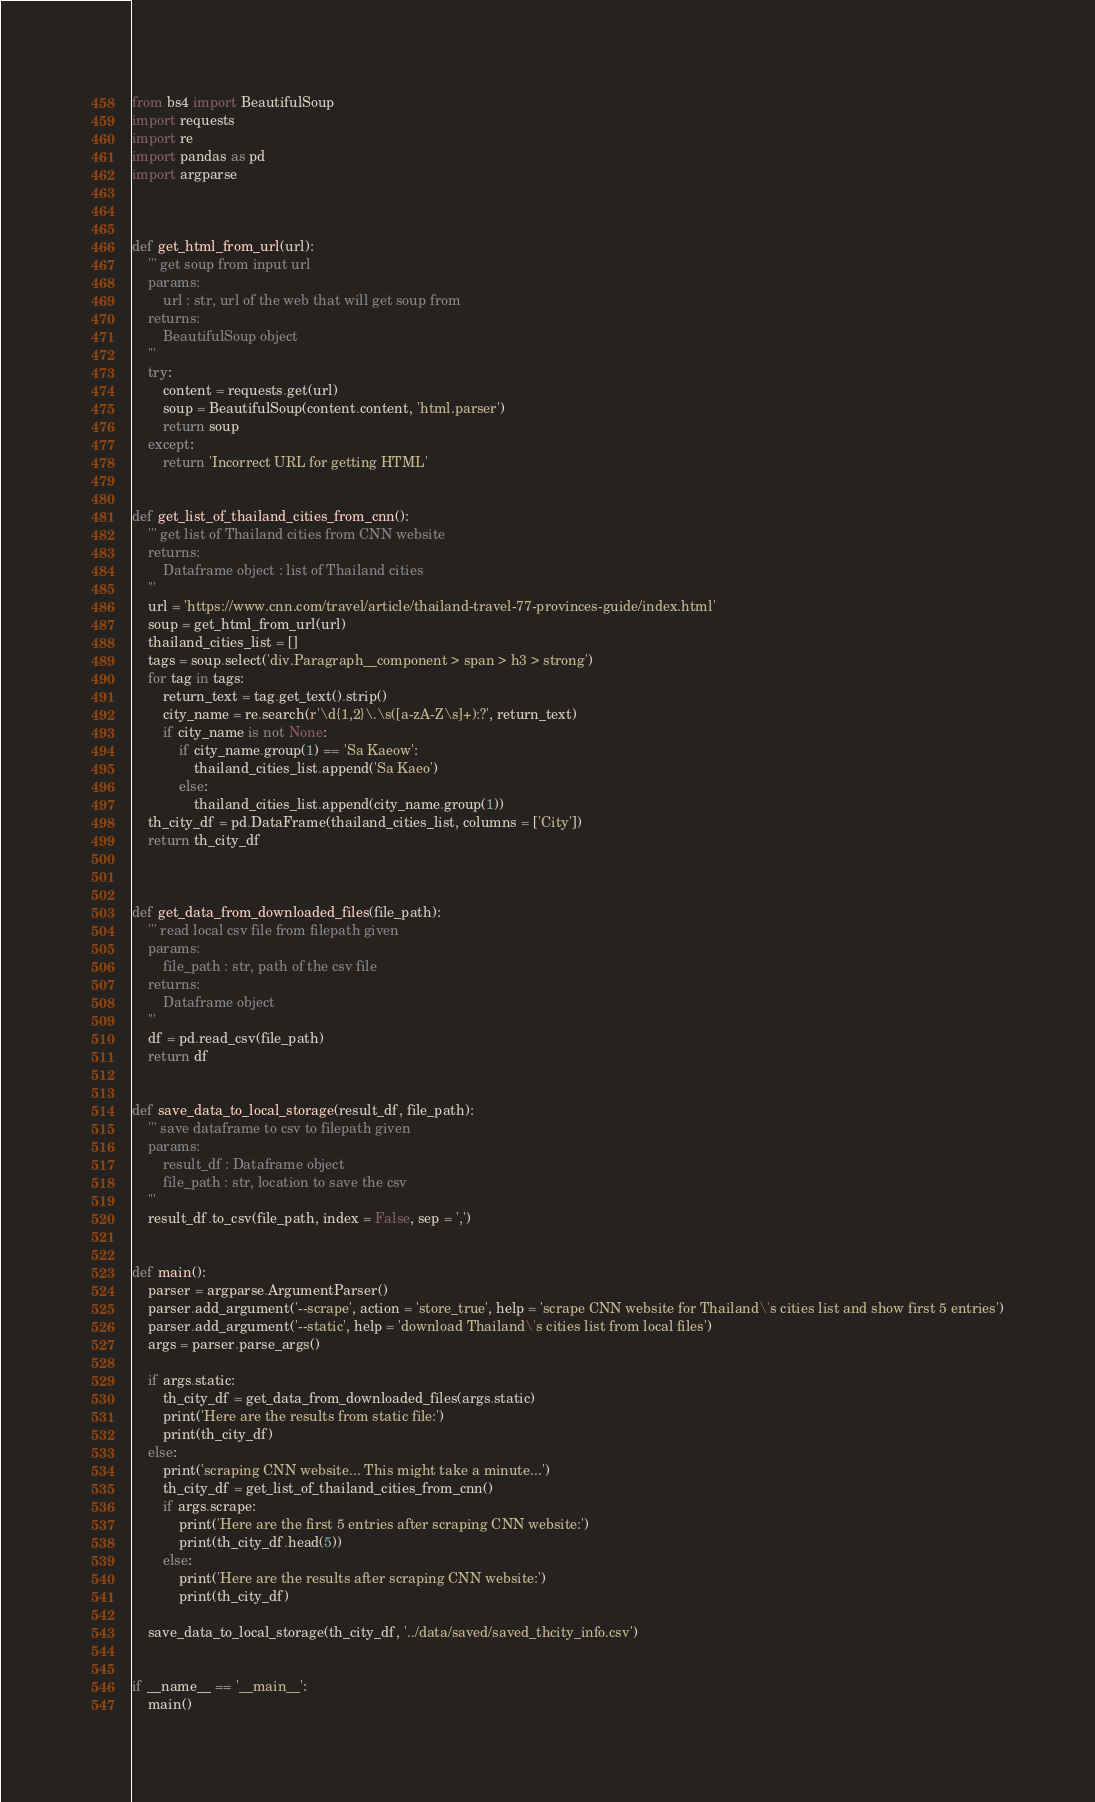<code> <loc_0><loc_0><loc_500><loc_500><_Python_>from bs4 import BeautifulSoup
import requests
import re
import pandas as pd
import argparse



def get_html_from_url(url):
    ''' get soup from input url
    params:
        url : str, url of the web that will get soup from
    returns: 
        BeautifulSoup object
    '''
    try:
        content = requests.get(url)
        soup = BeautifulSoup(content.content, 'html.parser')
        return soup
    except:
        return 'Incorrect URL for getting HTML'
    
    
def get_list_of_thailand_cities_from_cnn():
    ''' get list of Thailand cities from CNN website
    returns:
        Dataframe object : list of Thailand cities
    '''
    url = 'https://www.cnn.com/travel/article/thailand-travel-77-provinces-guide/index.html'
    soup = get_html_from_url(url)
    thailand_cities_list = []
    tags = soup.select('div.Paragraph__component > span > h3 > strong')
    for tag in tags:
        return_text = tag.get_text().strip()
        city_name = re.search(r'\d{1,2}\.\s([a-zA-Z\s]+):?', return_text)
        if city_name is not None:
            if city_name.group(1) == 'Sa Kaeow':
                thailand_cities_list.append('Sa Kaeo')
            else:
                thailand_cities_list.append(city_name.group(1))
    th_city_df = pd.DataFrame(thailand_cities_list, columns = ['City'])
    return th_city_df
    


def get_data_from_downloaded_files(file_path):
    ''' read local csv file from filepath given
    params:
        file_path : str, path of the csv file
    returns:
        Dataframe object
    '''
    df = pd.read_csv(file_path)
    return df


def save_data_to_local_storage(result_df, file_path):
    ''' save dataframe to csv to filepath given
    params:
        result_df : Dataframe object
        file_path : str, location to save the csv
    '''
    result_df.to_csv(file_path, index = False, sep = ',')


def main():
    parser = argparse.ArgumentParser()
    parser.add_argument('--scrape', action = 'store_true', help = 'scrape CNN website for Thailand\'s cities list and show first 5 entries')
    parser.add_argument('--static', help = 'download Thailand\'s cities list from local files')
    args = parser.parse_args()

    if args.static:
        th_city_df = get_data_from_downloaded_files(args.static)
        print('Here are the results from static file:')
        print(th_city_df)
    else:
        print('scraping CNN website... This might take a minute...')
        th_city_df = get_list_of_thailand_cities_from_cnn()
        if args.scrape:
            print('Here are the first 5 entries after scraping CNN website:')
            print(th_city_df.head(5))
        else:
            print('Here are the results after scraping CNN website:')
            print(th_city_df)

    save_data_to_local_storage(th_city_df, '../data/saved/saved_thcity_info.csv')


if __name__ == '__main__':
    main()


</code> 